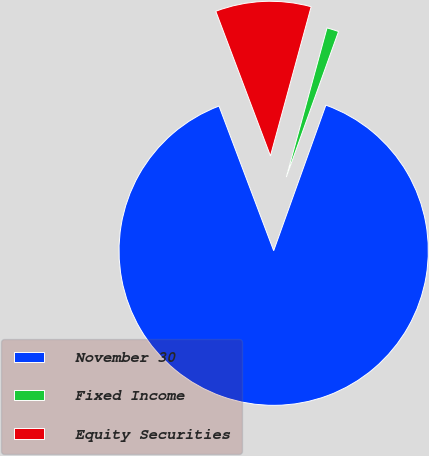Convert chart to OTSL. <chart><loc_0><loc_0><loc_500><loc_500><pie_chart><fcel>November 30<fcel>Fixed Income<fcel>Equity Securities<nl><fcel>88.77%<fcel>1.24%<fcel>9.99%<nl></chart> 